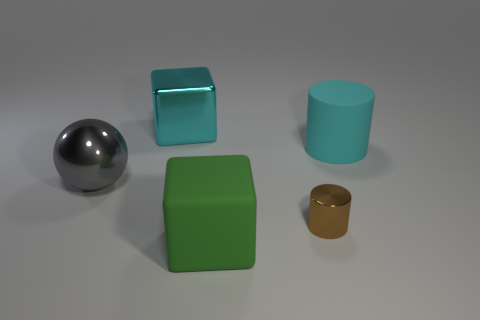Is there a sphere that has the same size as the cyan matte cylinder?
Offer a very short reply. Yes. Is the number of big rubber cubes behind the brown metallic object the same as the number of green blocks that are in front of the large cyan metal block?
Offer a terse response. No. Are there more cylinders than large green metallic spheres?
Your answer should be very brief. Yes. How many matte objects are either large green objects or tiny yellow objects?
Make the answer very short. 1. What number of large matte things are the same color as the big metal cube?
Provide a succinct answer. 1. What is the material of the big cyan thing that is left of the rubber thing behind the green object in front of the large gray ball?
Provide a short and direct response. Metal. What is the color of the metallic thing that is right of the cyan thing left of the large green matte object?
Your response must be concise. Brown. How many large things are either red metallic spheres or brown things?
Make the answer very short. 0. What number of spheres are made of the same material as the large cyan cylinder?
Provide a short and direct response. 0. There is a cylinder behind the small object; what is its size?
Give a very brief answer. Large. 